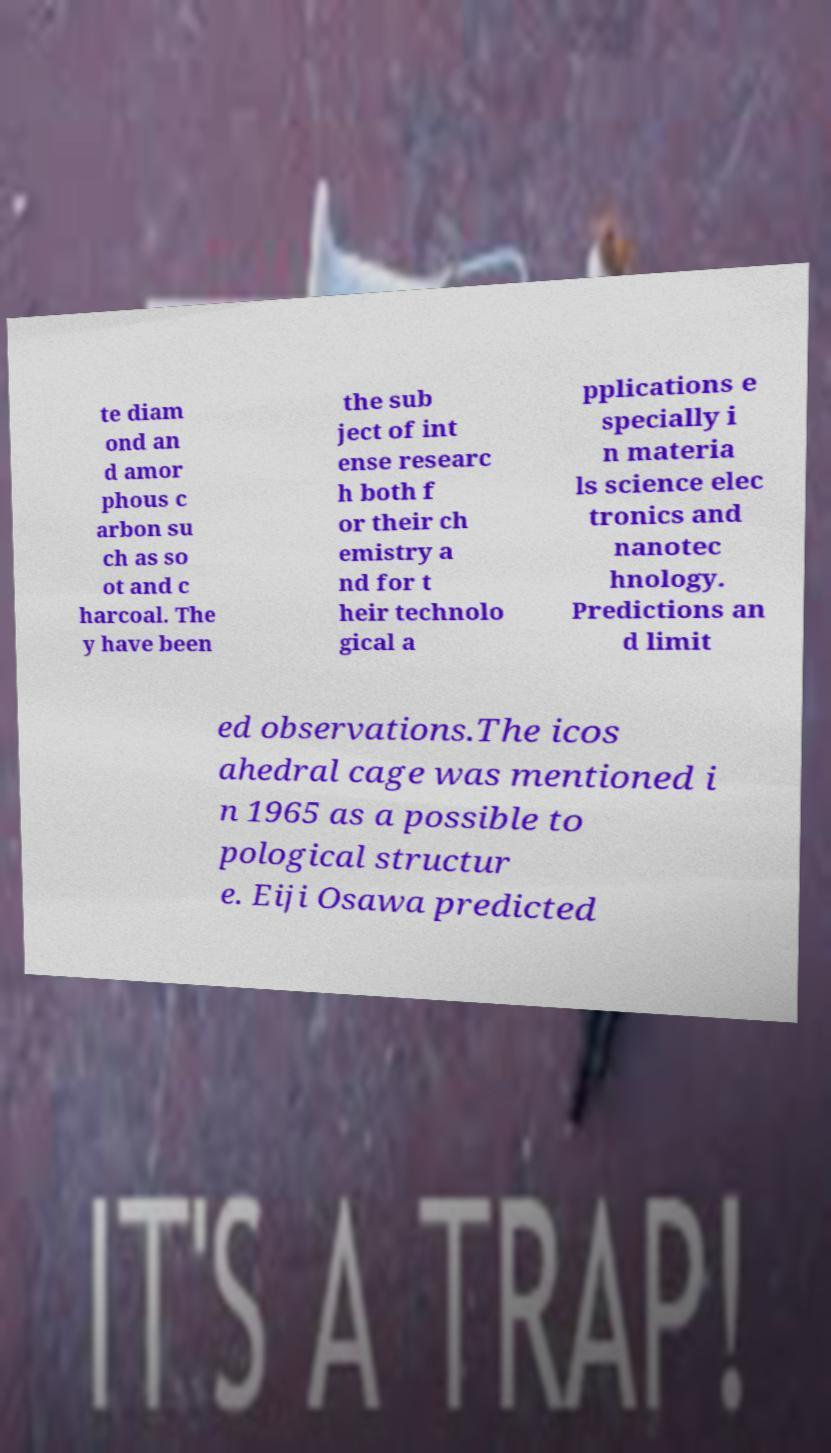What messages or text are displayed in this image? I need them in a readable, typed format. te diam ond an d amor phous c arbon su ch as so ot and c harcoal. The y have been the sub ject of int ense researc h both f or their ch emistry a nd for t heir technolo gical a pplications e specially i n materia ls science elec tronics and nanotec hnology. Predictions an d limit ed observations.The icos ahedral cage was mentioned i n 1965 as a possible to pological structur e. Eiji Osawa predicted 